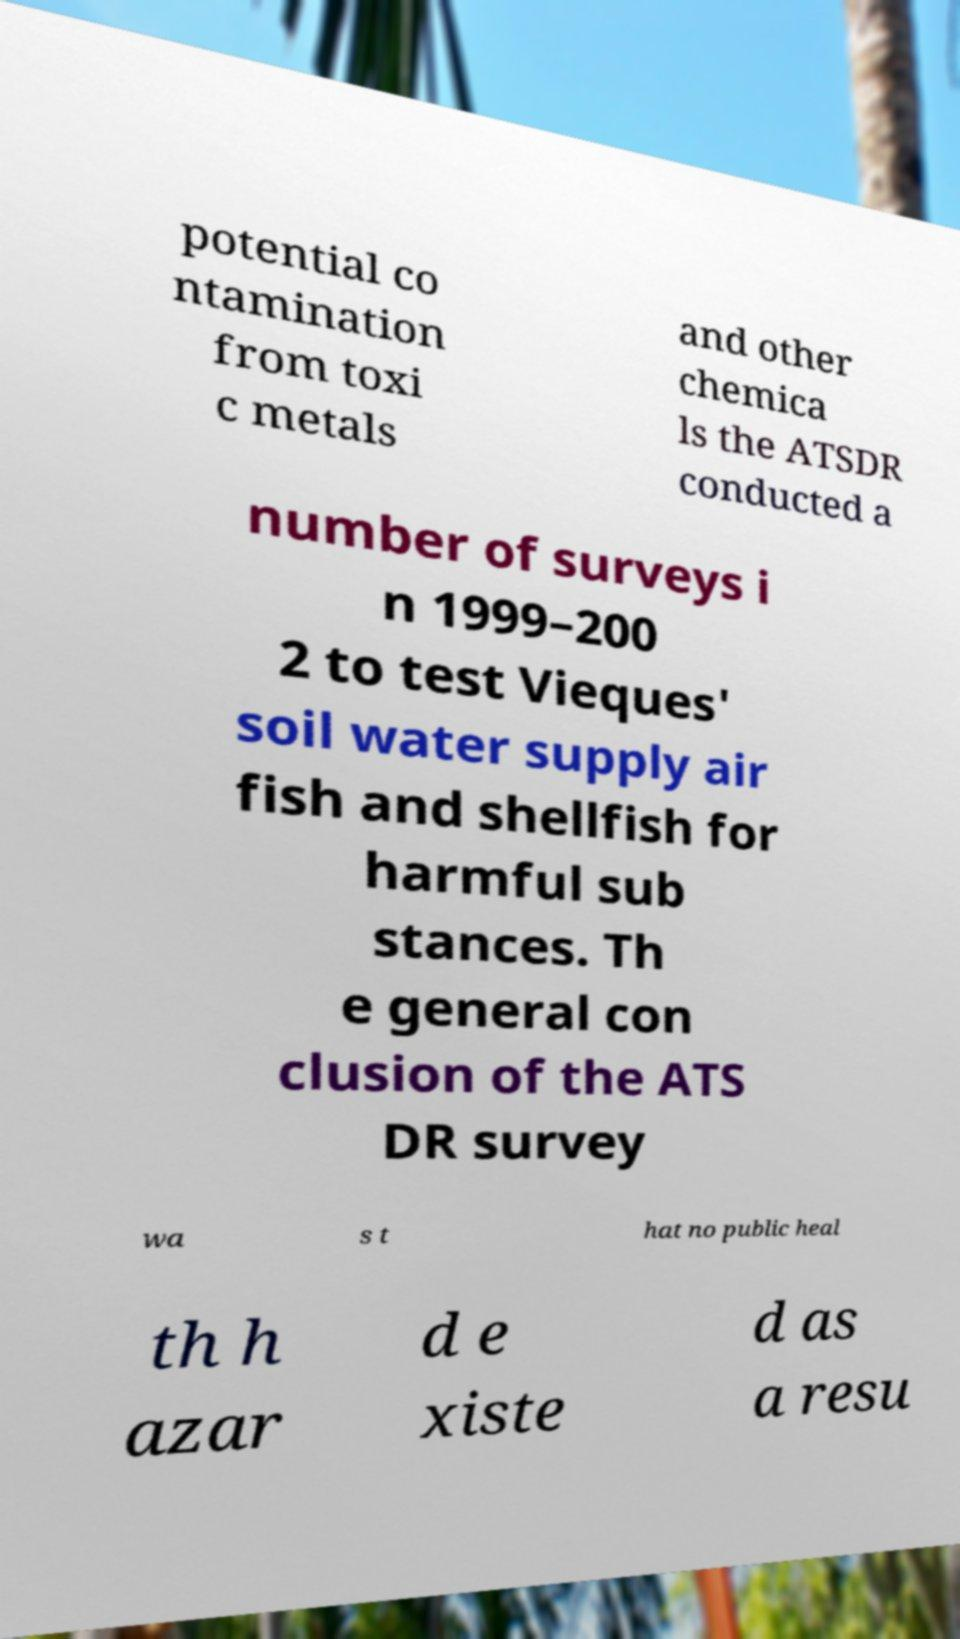What messages or text are displayed in this image? I need them in a readable, typed format. potential co ntamination from toxi c metals and other chemica ls the ATSDR conducted a number of surveys i n 1999–200 2 to test Vieques' soil water supply air fish and shellfish for harmful sub stances. Th e general con clusion of the ATS DR survey wa s t hat no public heal th h azar d e xiste d as a resu 